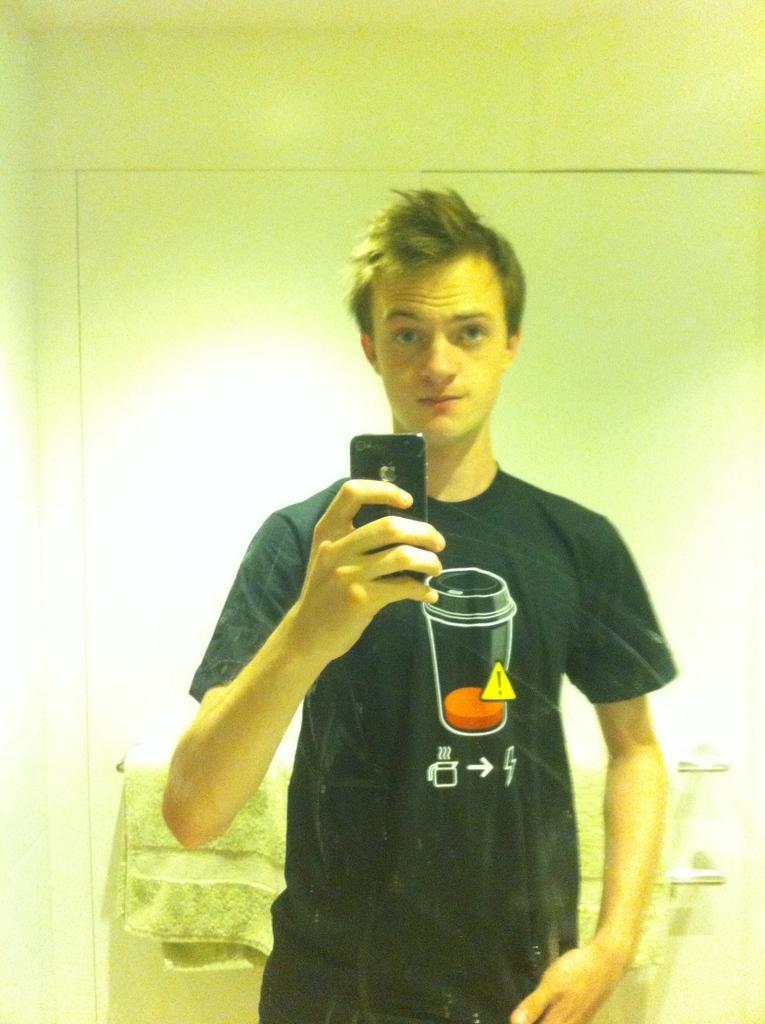Describe this image in one or two sentences. In this image, we can see a person in front of the wall. This person is wearing clothes and holding phone with his hand. There is a towel in the bottom left of the image. 